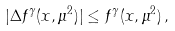Convert formula to latex. <formula><loc_0><loc_0><loc_500><loc_500>| \Delta f ^ { \gamma } ( x , \mu ^ { 2 } ) | \leq f ^ { \gamma } ( x , \mu ^ { 2 } ) \, ,</formula> 